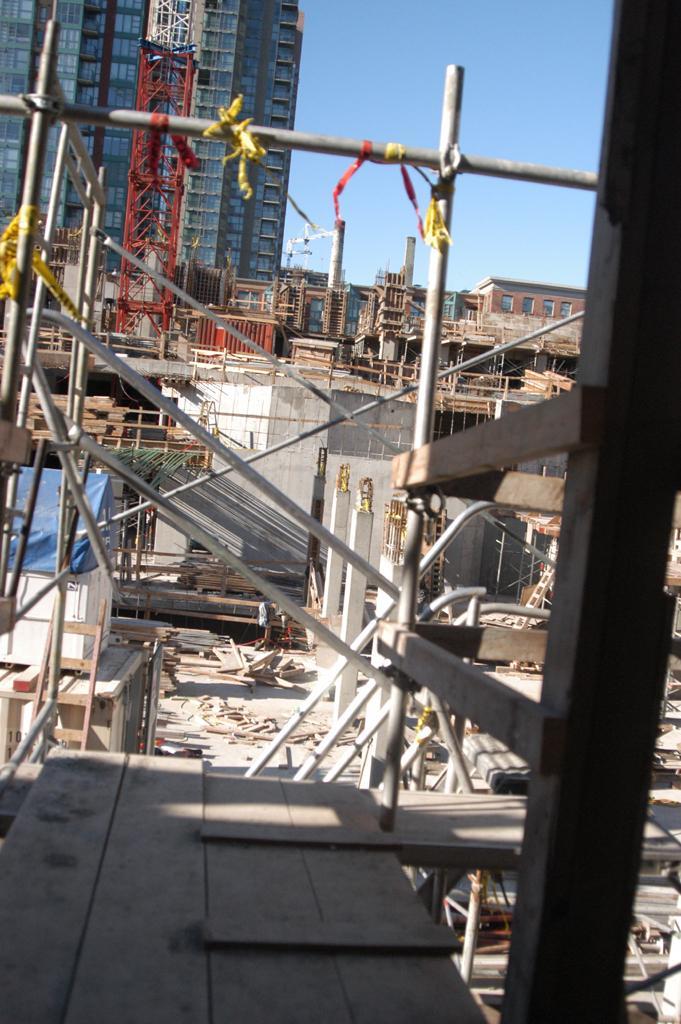Describe this image in one or two sentences. In the picture we can see a construction site with poles and pillars and behind it, we can see the tower building with many floors and glasses to it and beside it we can see a part of the sky. 